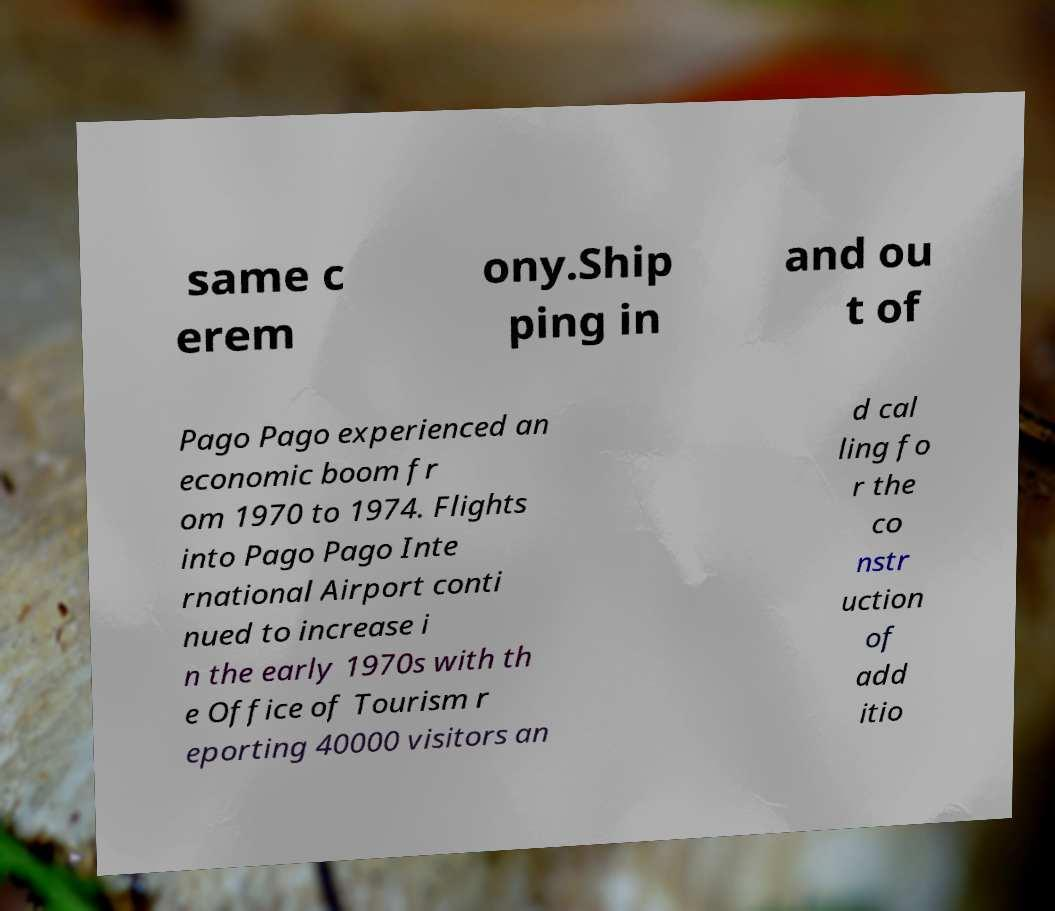There's text embedded in this image that I need extracted. Can you transcribe it verbatim? same c erem ony.Ship ping in and ou t of Pago Pago experienced an economic boom fr om 1970 to 1974. Flights into Pago Pago Inte rnational Airport conti nued to increase i n the early 1970s with th e Office of Tourism r eporting 40000 visitors an d cal ling fo r the co nstr uction of add itio 